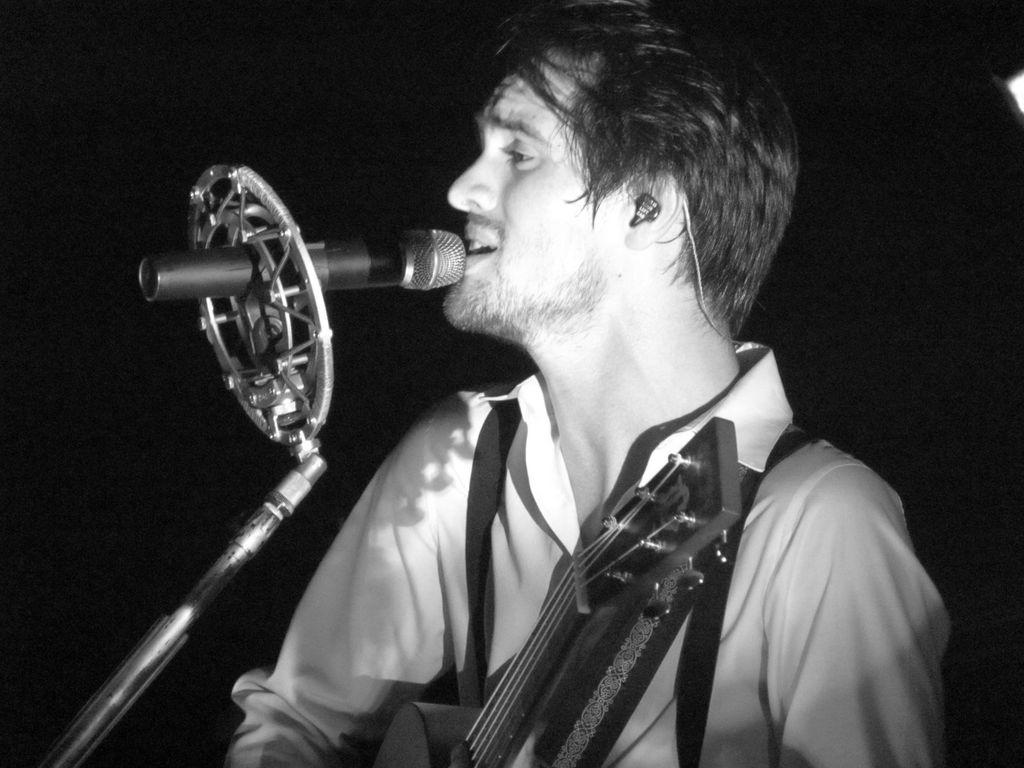What is the main subject of the image? There is a person in the image. What is the person doing in the image? The person is holding a musical instrument and singing. What object is in front of the person? There is a microphone (mic) in front of the person. What type of root can be seen growing from the person's head in the image? There is no root growing from the person's head in the image. How does the person use the brake while playing the musical instrument in the image? The person is not using a brake in the image, as they are playing a musical instrument and singing. 